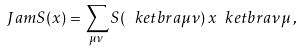<formula> <loc_0><loc_0><loc_500><loc_500>\ J a m S ( x ) = \sum _ { \mu \nu } S ( \ k e t b r a \mu \nu ) \, x \ k e t b r a \nu \mu \, ,</formula> 